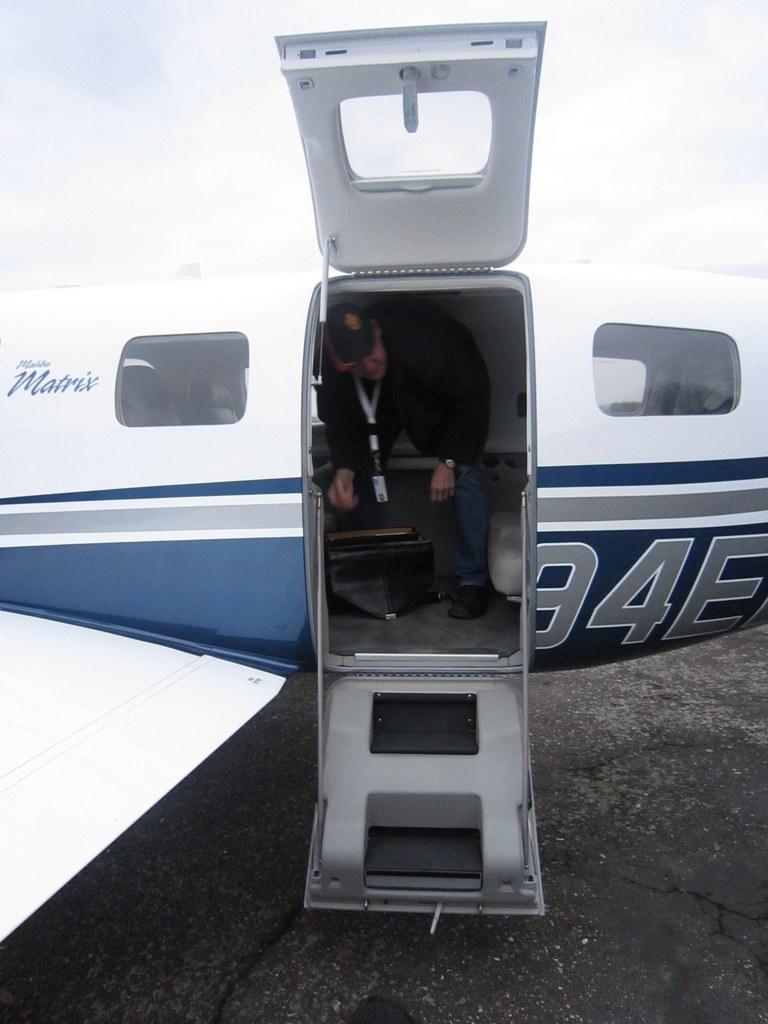Describe this image in one or two sentences. In this picture we can see an airplane, there is a person in the airline, we can see the sky at the top of the picture. 